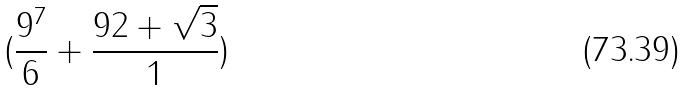<formula> <loc_0><loc_0><loc_500><loc_500>( \frac { 9 ^ { 7 } } { 6 } + \frac { 9 2 + \sqrt { 3 } } { 1 } )</formula> 